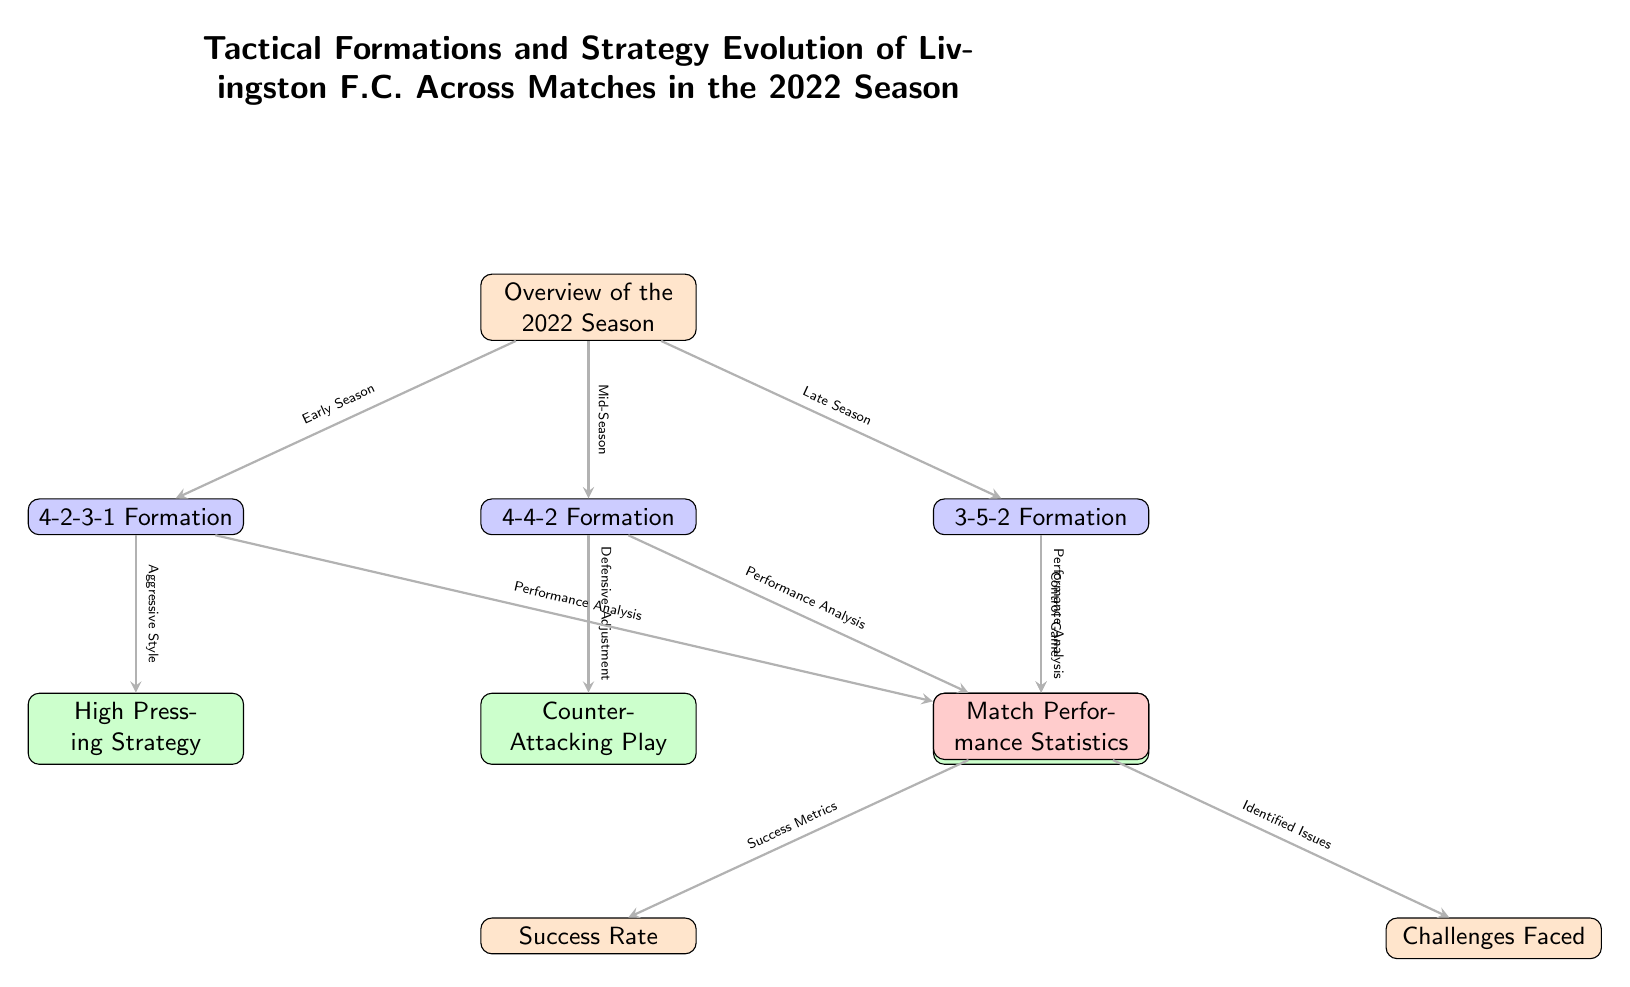What is the formation used in the early season? The diagram indicates that the formation used in the early season is '4-2-3-1 Formation', which is represented as a node below the overview node for the early season transition.
Answer: 4-2-3-1 Formation Which strategy is associated with the 4-4-2 formation? The diagram shows an arrow pointing from the 4-4-2 Formation to the 'Counter-Attacking Play' strategy, indicating that this is the strategy employed in conjunction with that formation.
Answer: Counter-Attacking Play How many tactical formations are presented in the diagram? By counting the nodes under the 'Overview of the 2022 Season', there are three tactical formations listed: '4-2-3-1', '4-4-2', and '3-5-2'.
Answer: 3 What is the outcome of the '3-5-2 Formation? The diagram indicates that '3-5-2 Formation' evolves into the 'Possession-Based Play' strategy, highlighting its intended outcome.
Answer: Possession-Based Play What directed relationship exists between 'Match Performance Statistics' and 'Success Rate'? An arrow in the diagram indicates that there is a directional flow from 'Match Performance Statistics' to 'Success Rate', showing that success metrics are derived from overall match statistics.
Answer: Success Rate What does 'Aggressive Style' lead to in the diagram? The arrow from '4-2-3-1 Formation' to 'High Pressing Strategy' signifies that an aggressive style is utilized, leading to the high pressing strategy during early matches.
Answer: High Pressing Strategy Which part of the season does '4-4-2 Formation' pertain to? The diagram illustrates that '4-4-2 Formation' is associated with the mid-season phase, evidenced by the placement of the node under the 'Mid-Season' transition.
Answer: Mid-Season What challenges faced Livingston F.C. according to the diagram? The node labeled 'Challenges Faced' is directly linked to the 'Match Performance Statistics', implying that the identified issues arise from performance metrics analyzed throughout the matches.
Answer: Challenges Faced 